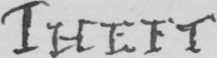What text is written in this handwritten line? THEFT 